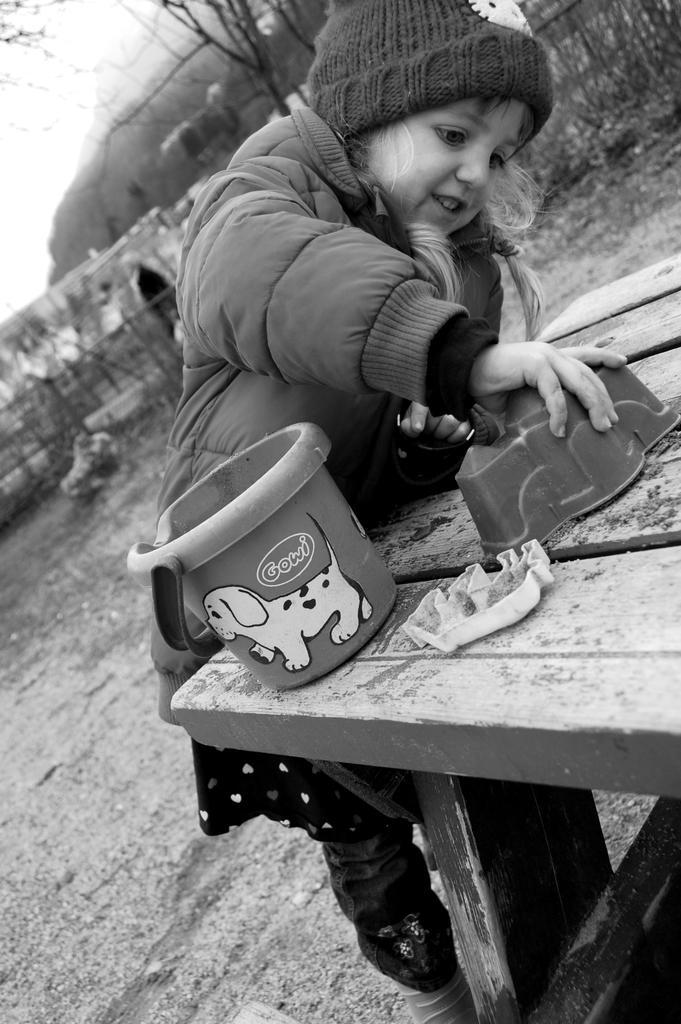How would you summarize this image in a sentence or two? In the given image we can see that a child is standing. There is a bench in front of her. This is a bucket. She is wearing a jacket and a cap. This is a tree. 